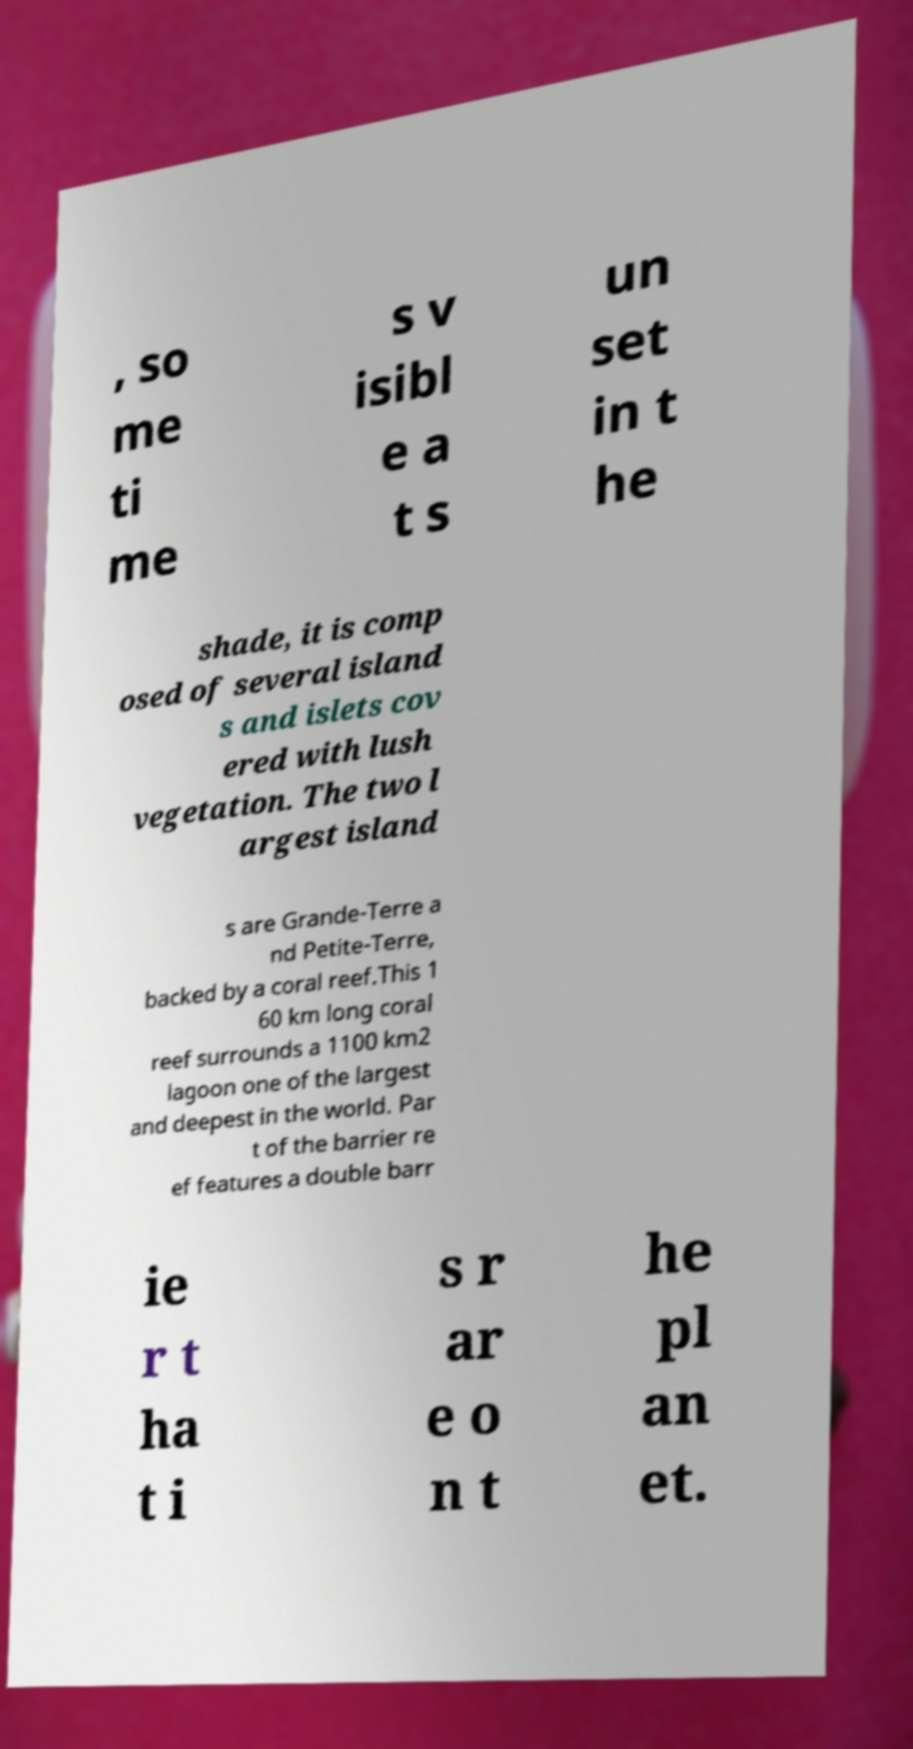For documentation purposes, I need the text within this image transcribed. Could you provide that? , so me ti me s v isibl e a t s un set in t he shade, it is comp osed of several island s and islets cov ered with lush vegetation. The two l argest island s are Grande-Terre a nd Petite-Terre, backed by a coral reef.This 1 60 km long coral reef surrounds a 1100 km2 lagoon one of the largest and deepest in the world. Par t of the barrier re ef features a double barr ie r t ha t i s r ar e o n t he pl an et. 